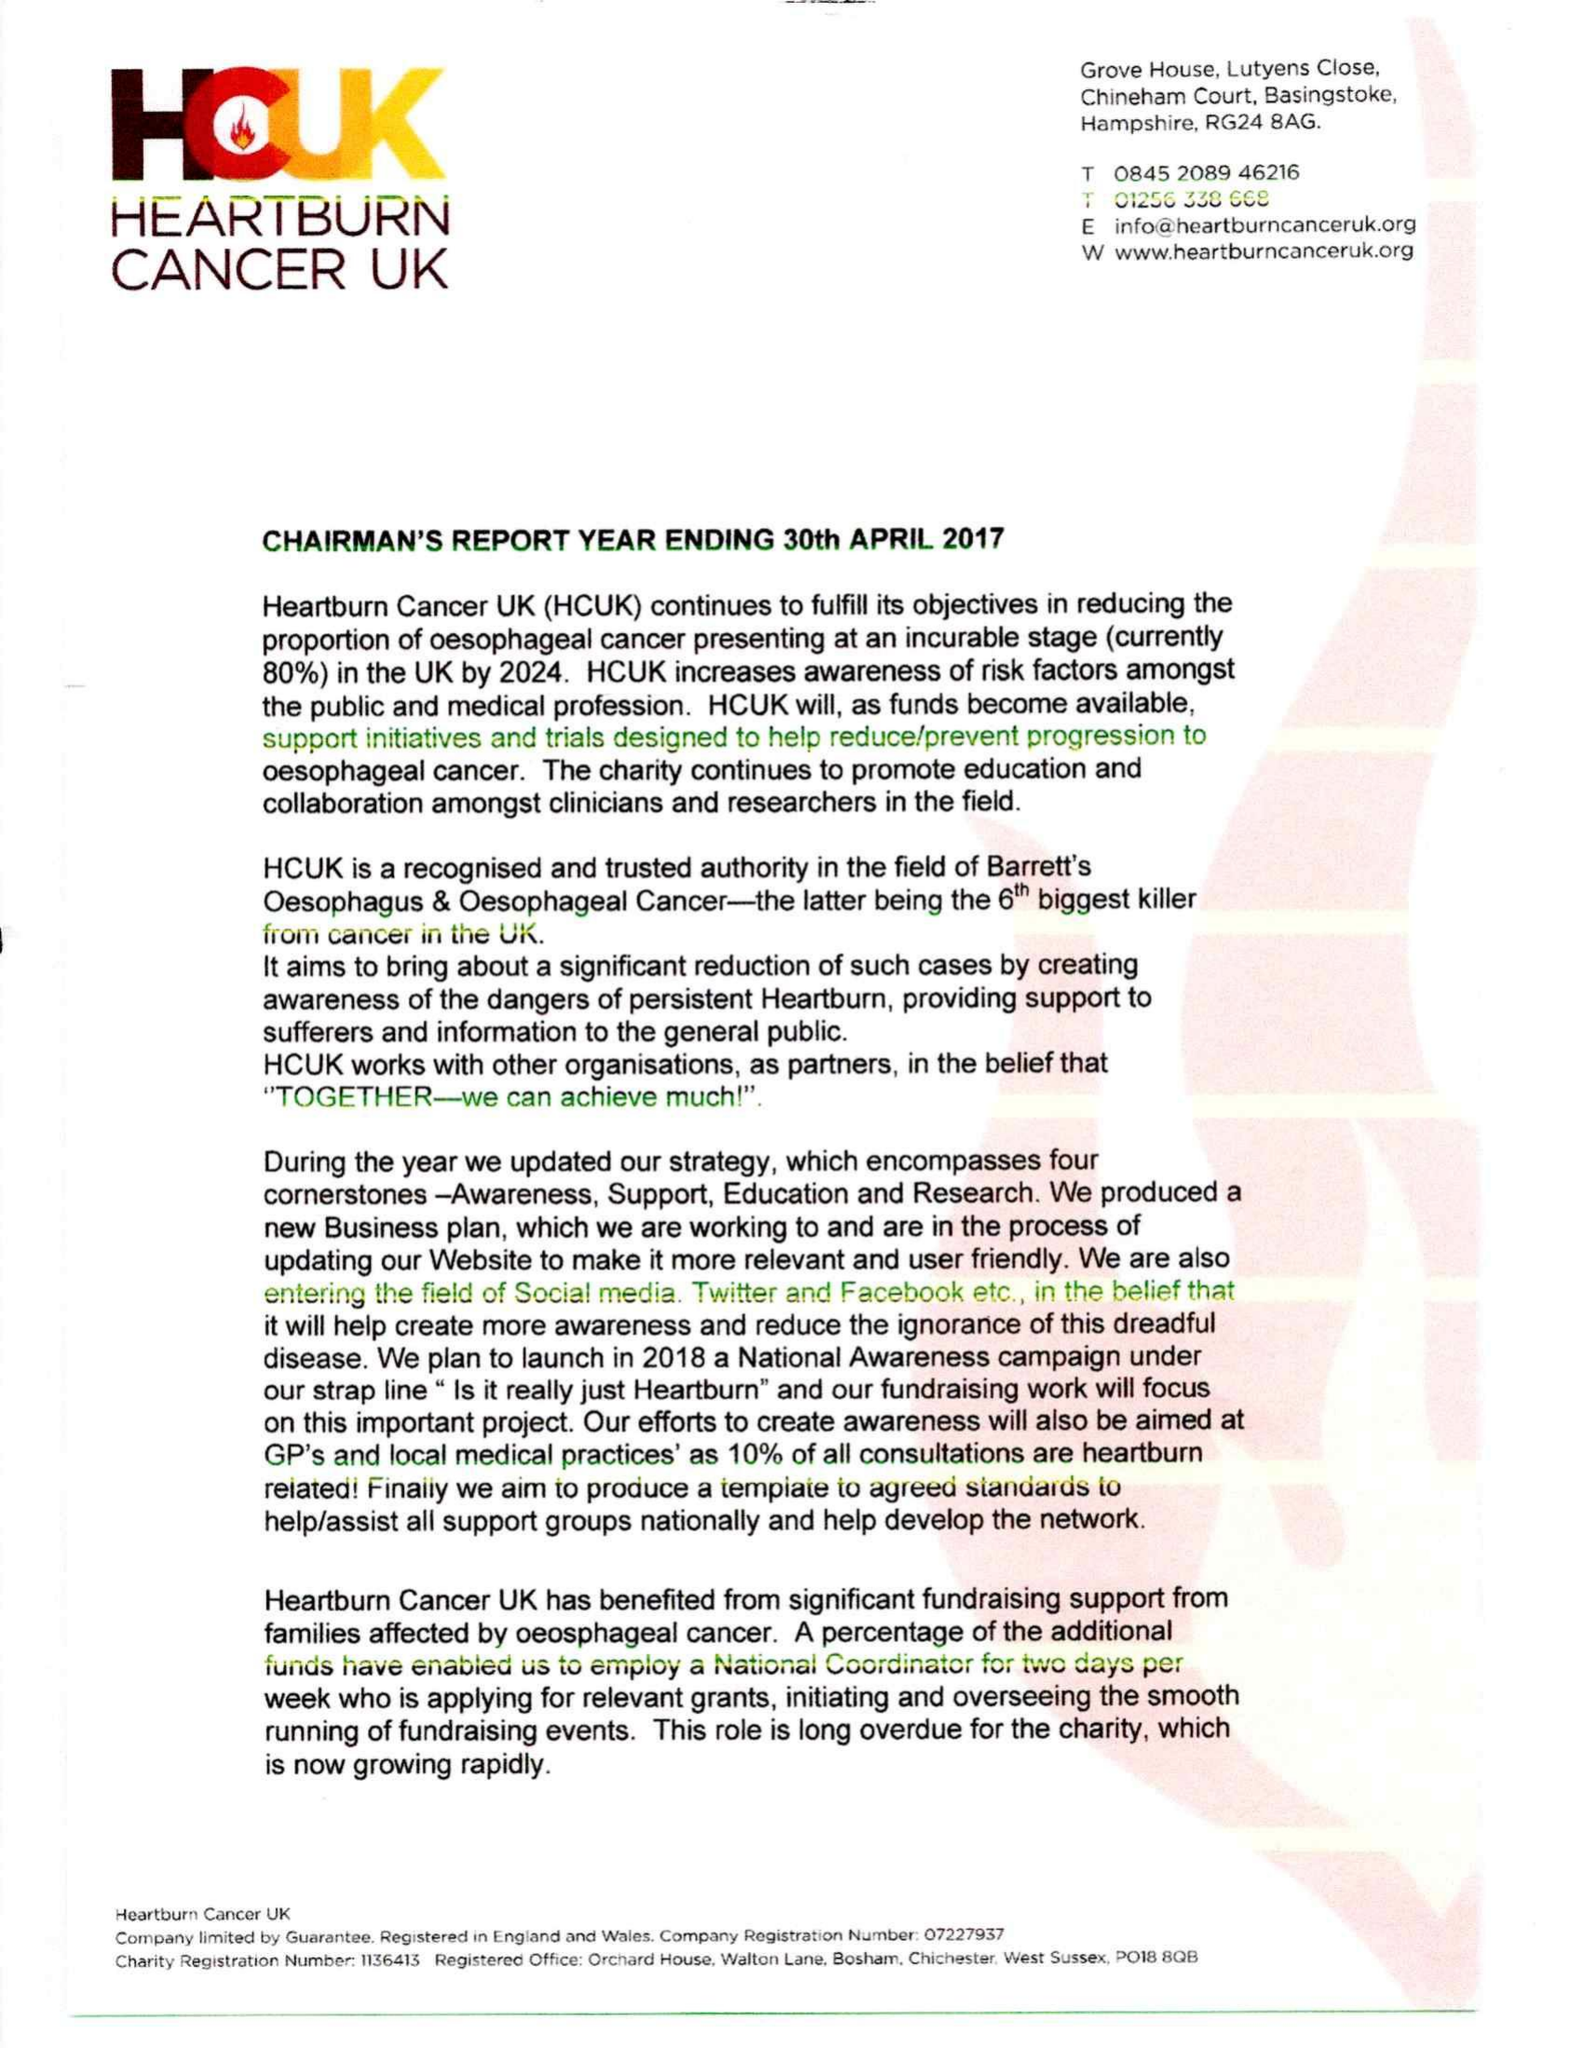What is the value for the charity_name?
Answer the question using a single word or phrase. Heartburn Cancer Uk 